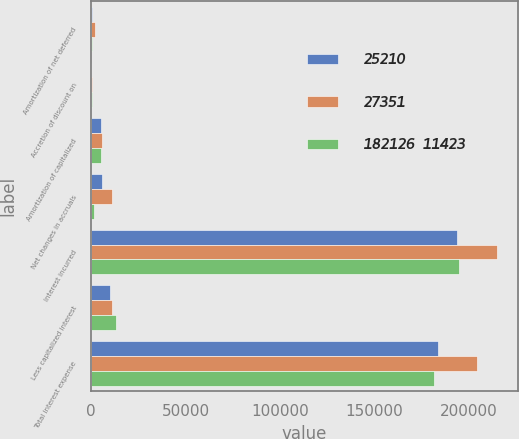Convert chart. <chart><loc_0><loc_0><loc_500><loc_500><stacked_bar_chart><ecel><fcel>Amortization of net deferred<fcel>Accretion of discount on<fcel>Amortization of capitalized<fcel>Net changes in accruals<fcel>Interest incurred<fcel>Less capitalized interest<fcel>Total interest expense<nl><fcel>25210<fcel>349<fcel>193<fcel>5260<fcel>5709<fcel>193642<fcel>9892<fcel>183750<nl><fcel>27351<fcel>2018<fcel>257<fcel>5937<fcel>10842<fcel>215070<fcel>10848<fcel>204222<nl><fcel>182126  11423<fcel>573<fcel>315<fcel>5385<fcel>1768<fcel>194966<fcel>13362<fcel>181604<nl></chart> 